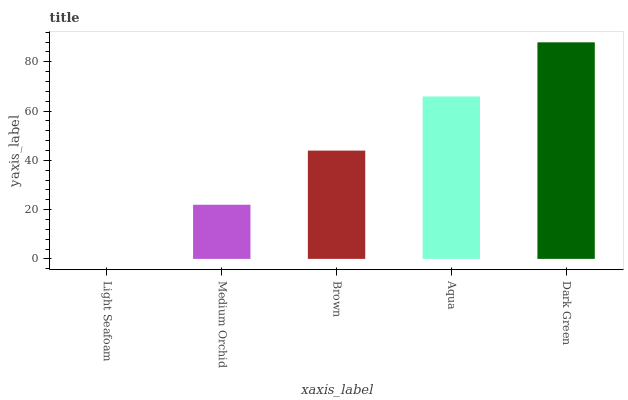Is Light Seafoam the minimum?
Answer yes or no. Yes. Is Dark Green the maximum?
Answer yes or no. Yes. Is Medium Orchid the minimum?
Answer yes or no. No. Is Medium Orchid the maximum?
Answer yes or no. No. Is Medium Orchid greater than Light Seafoam?
Answer yes or no. Yes. Is Light Seafoam less than Medium Orchid?
Answer yes or no. Yes. Is Light Seafoam greater than Medium Orchid?
Answer yes or no. No. Is Medium Orchid less than Light Seafoam?
Answer yes or no. No. Is Brown the high median?
Answer yes or no. Yes. Is Brown the low median?
Answer yes or no. Yes. Is Dark Green the high median?
Answer yes or no. No. Is Aqua the low median?
Answer yes or no. No. 